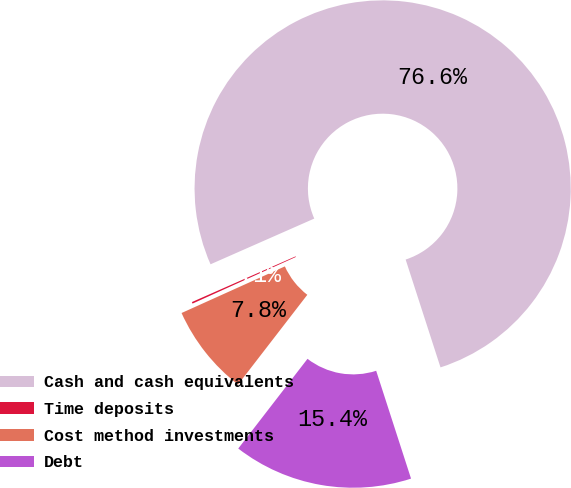Convert chart to OTSL. <chart><loc_0><loc_0><loc_500><loc_500><pie_chart><fcel>Cash and cash equivalents<fcel>Time deposits<fcel>Cost method investments<fcel>Debt<nl><fcel>76.63%<fcel>0.14%<fcel>7.79%<fcel>15.44%<nl></chart> 